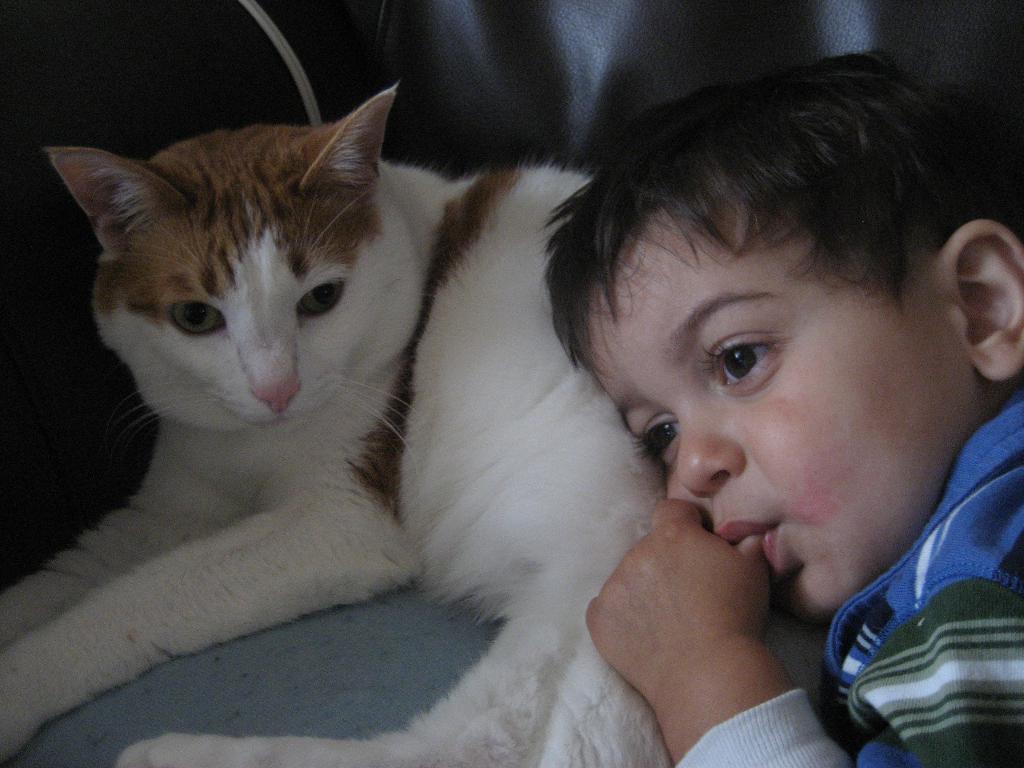Could you give a brief overview of what you see in this image? In this image we can see a cat and child. 